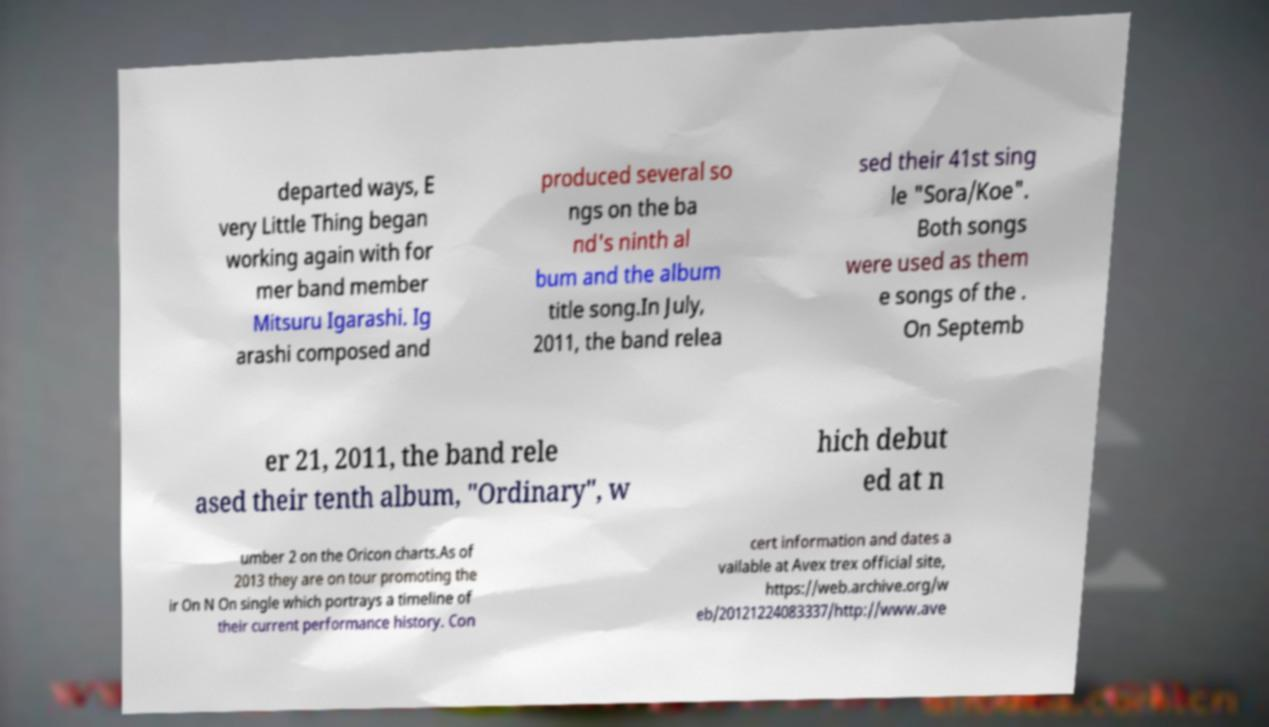Could you assist in decoding the text presented in this image and type it out clearly? departed ways, E very Little Thing began working again with for mer band member Mitsuru Igarashi. Ig arashi composed and produced several so ngs on the ba nd's ninth al bum and the album title song.In July, 2011, the band relea sed their 41st sing le "Sora/Koe". Both songs were used as them e songs of the . On Septemb er 21, 2011, the band rele ased their tenth album, "Ordinary", w hich debut ed at n umber 2 on the Oricon charts.As of 2013 they are on tour promoting the ir On N On single which portrays a timeline of their current performance history. Con cert information and dates a vailable at Avex trex official site, https://web.archive.org/w eb/20121224083337/http://www.ave 